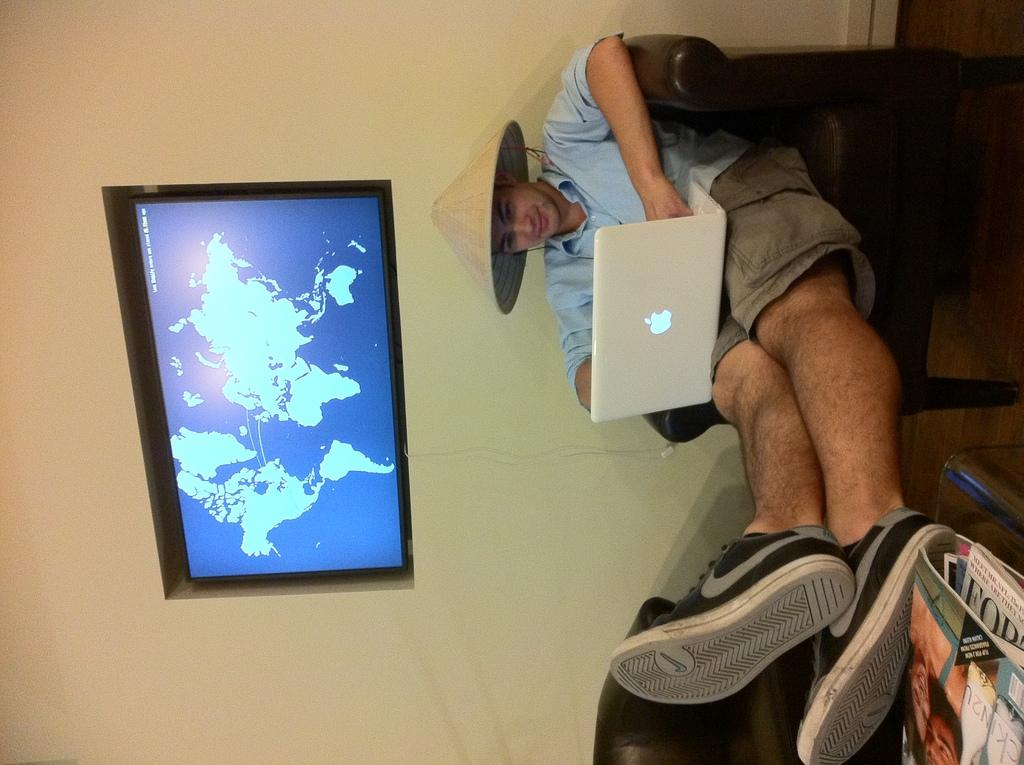Who is present in the image? There is a man in the image. What is the man doing in the image? The man is seated in a chair. What is the man wearing on his head? The man is wearing a cap. What device is the man using in the image? The man has a laptop on his legs. What electronic device is on the wall in the image? There is a television on the wall in the image. What items can be seen on the table in the image? There are books on a table in the image. What color are the man's toes in the image? There is no information about the man's toes in the image, so we cannot determine their color. 